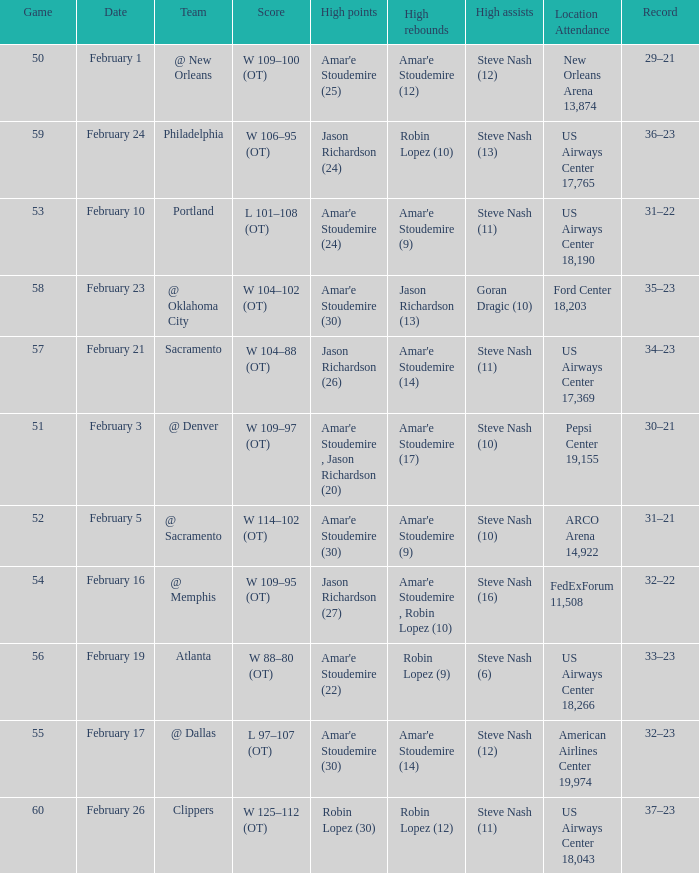Name the date for score w 109–95 (ot) February 16. 